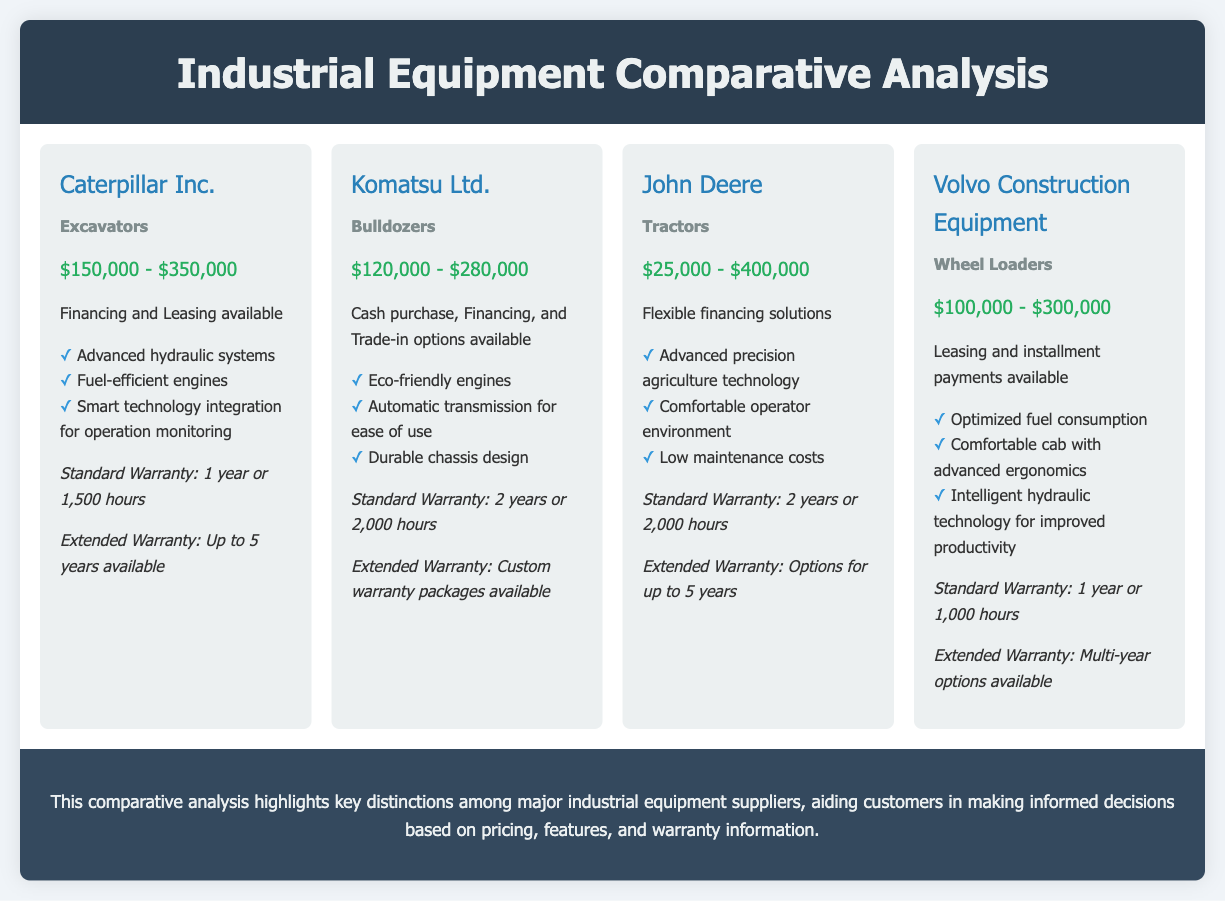What is the price range for Caterpillar Inc. excavators? The price range is clearly listed under the supplier information for Caterpillar Inc.
Answer: $150,000 - $350,000 What is the warranty period offered by Komatsu Ltd.? The warranty information for Komatsu Ltd. specifies the standard warranty details.
Answer: 2 years or 2,000 hours What financing options are available for Volvo Construction Equipment? The available financing options are mentioned in the supplier's equipment details.
Answer: Leasing and installment payments Which supplier offers tractors? The equipment types for each supplier are listed, indicating the supplier that provides tractors.
Answer: John Deere What is the feature related to engine efficiency provided by Komatsu Ltd.? The features list for Komatsu Ltd. includes a specific characteristic about its engines.
Answer: Eco-friendly engines How many suppliers provide extended warranty options? A review of the warranty information reveals the number of suppliers that mention extended warranty options.
Answer: 4 Which industrial equipment supplier has the lowest starting price? The starting prices for all suppliers can be compared to find the one with the lowest figure.
Answer: John Deere What specific technology does John Deere highlight for its tractors? The features list for John Deere allows for identification of the technology emphasized.
Answer: Advanced precision agriculture technology 